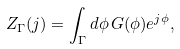<formula> <loc_0><loc_0><loc_500><loc_500>Z _ { \Gamma } ( j ) = \int _ { \Gamma } d \phi \, G ( \phi ) e ^ { j \phi } ,</formula> 